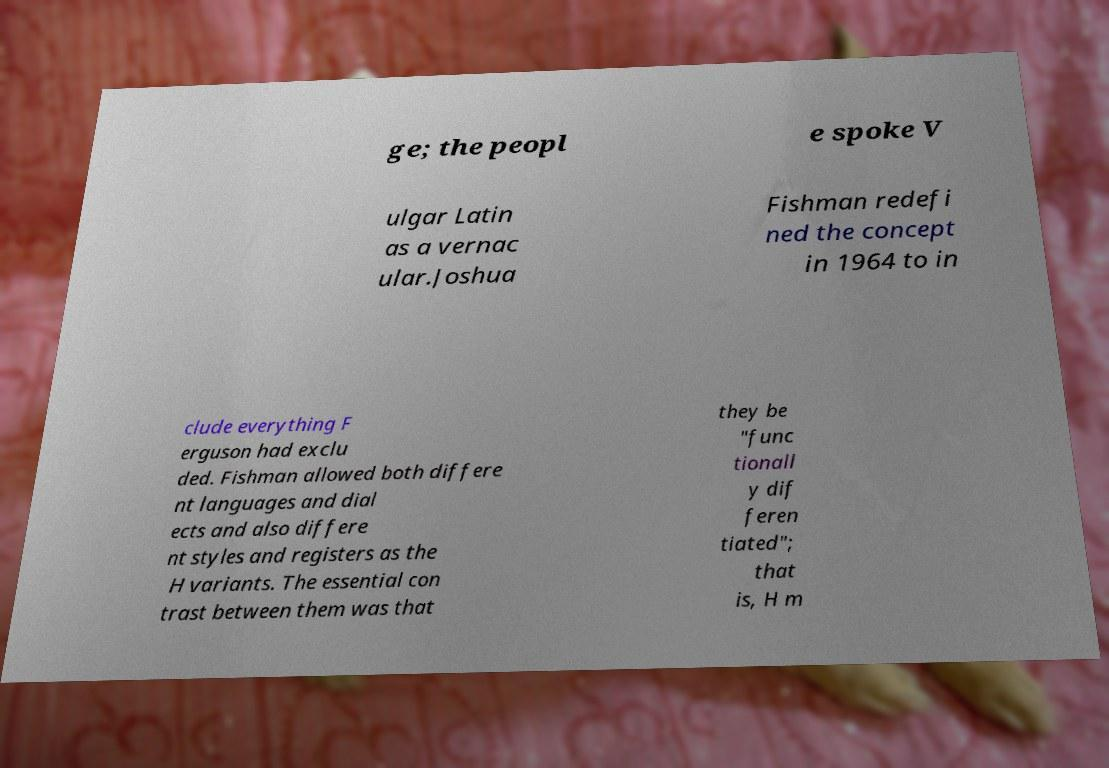Can you accurately transcribe the text from the provided image for me? ge; the peopl e spoke V ulgar Latin as a vernac ular.Joshua Fishman redefi ned the concept in 1964 to in clude everything F erguson had exclu ded. Fishman allowed both differe nt languages and dial ects and also differe nt styles and registers as the H variants. The essential con trast between them was that they be "func tionall y dif feren tiated"; that is, H m 